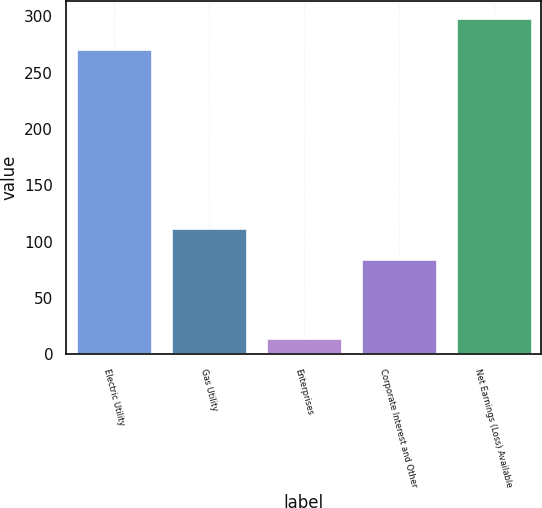<chart> <loc_0><loc_0><loc_500><loc_500><bar_chart><fcel>Electric Utility<fcel>Gas Utility<fcel>Enterprises<fcel>Corporate Interest and Other<fcel>Net Earnings (Loss) Available<nl><fcel>271<fcel>112.5<fcel>14<fcel>85<fcel>298.5<nl></chart> 